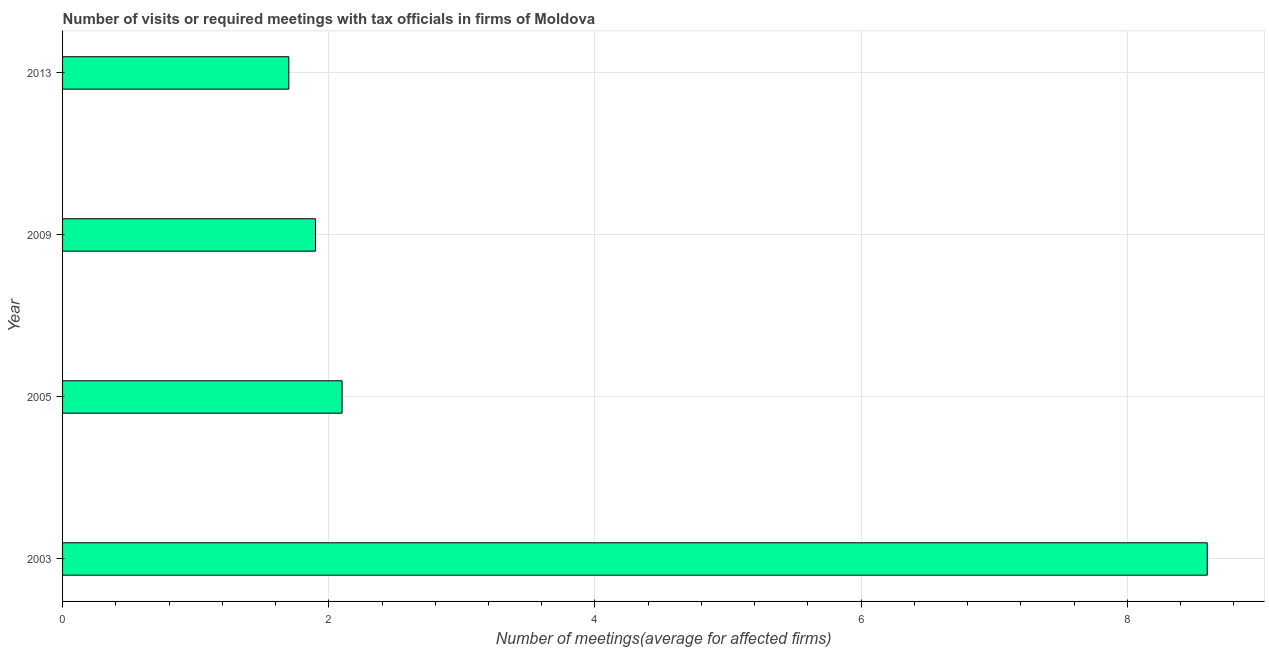Does the graph contain grids?
Your answer should be compact. Yes. What is the title of the graph?
Keep it short and to the point. Number of visits or required meetings with tax officials in firms of Moldova. What is the label or title of the X-axis?
Your answer should be compact. Number of meetings(average for affected firms). Across all years, what is the minimum number of required meetings with tax officials?
Keep it short and to the point. 1.7. In which year was the number of required meetings with tax officials maximum?
Keep it short and to the point. 2003. In which year was the number of required meetings with tax officials minimum?
Your response must be concise. 2013. What is the sum of the number of required meetings with tax officials?
Your answer should be compact. 14.3. What is the average number of required meetings with tax officials per year?
Offer a very short reply. 3.58. What is the median number of required meetings with tax officials?
Provide a succinct answer. 2. What is the ratio of the number of required meetings with tax officials in 2005 to that in 2013?
Your answer should be compact. 1.24. Is the difference between the number of required meetings with tax officials in 2003 and 2005 greater than the difference between any two years?
Your response must be concise. No. In how many years, is the number of required meetings with tax officials greater than the average number of required meetings with tax officials taken over all years?
Your response must be concise. 1. Are all the bars in the graph horizontal?
Ensure brevity in your answer.  Yes. How many years are there in the graph?
Give a very brief answer. 4. What is the difference between two consecutive major ticks on the X-axis?
Keep it short and to the point. 2. What is the Number of meetings(average for affected firms) in 2003?
Your answer should be compact. 8.6. What is the Number of meetings(average for affected firms) in 2009?
Ensure brevity in your answer.  1.9. What is the ratio of the Number of meetings(average for affected firms) in 2003 to that in 2005?
Your answer should be compact. 4.09. What is the ratio of the Number of meetings(average for affected firms) in 2003 to that in 2009?
Your answer should be compact. 4.53. What is the ratio of the Number of meetings(average for affected firms) in 2003 to that in 2013?
Offer a very short reply. 5.06. What is the ratio of the Number of meetings(average for affected firms) in 2005 to that in 2009?
Ensure brevity in your answer.  1.1. What is the ratio of the Number of meetings(average for affected firms) in 2005 to that in 2013?
Make the answer very short. 1.24. What is the ratio of the Number of meetings(average for affected firms) in 2009 to that in 2013?
Give a very brief answer. 1.12. 